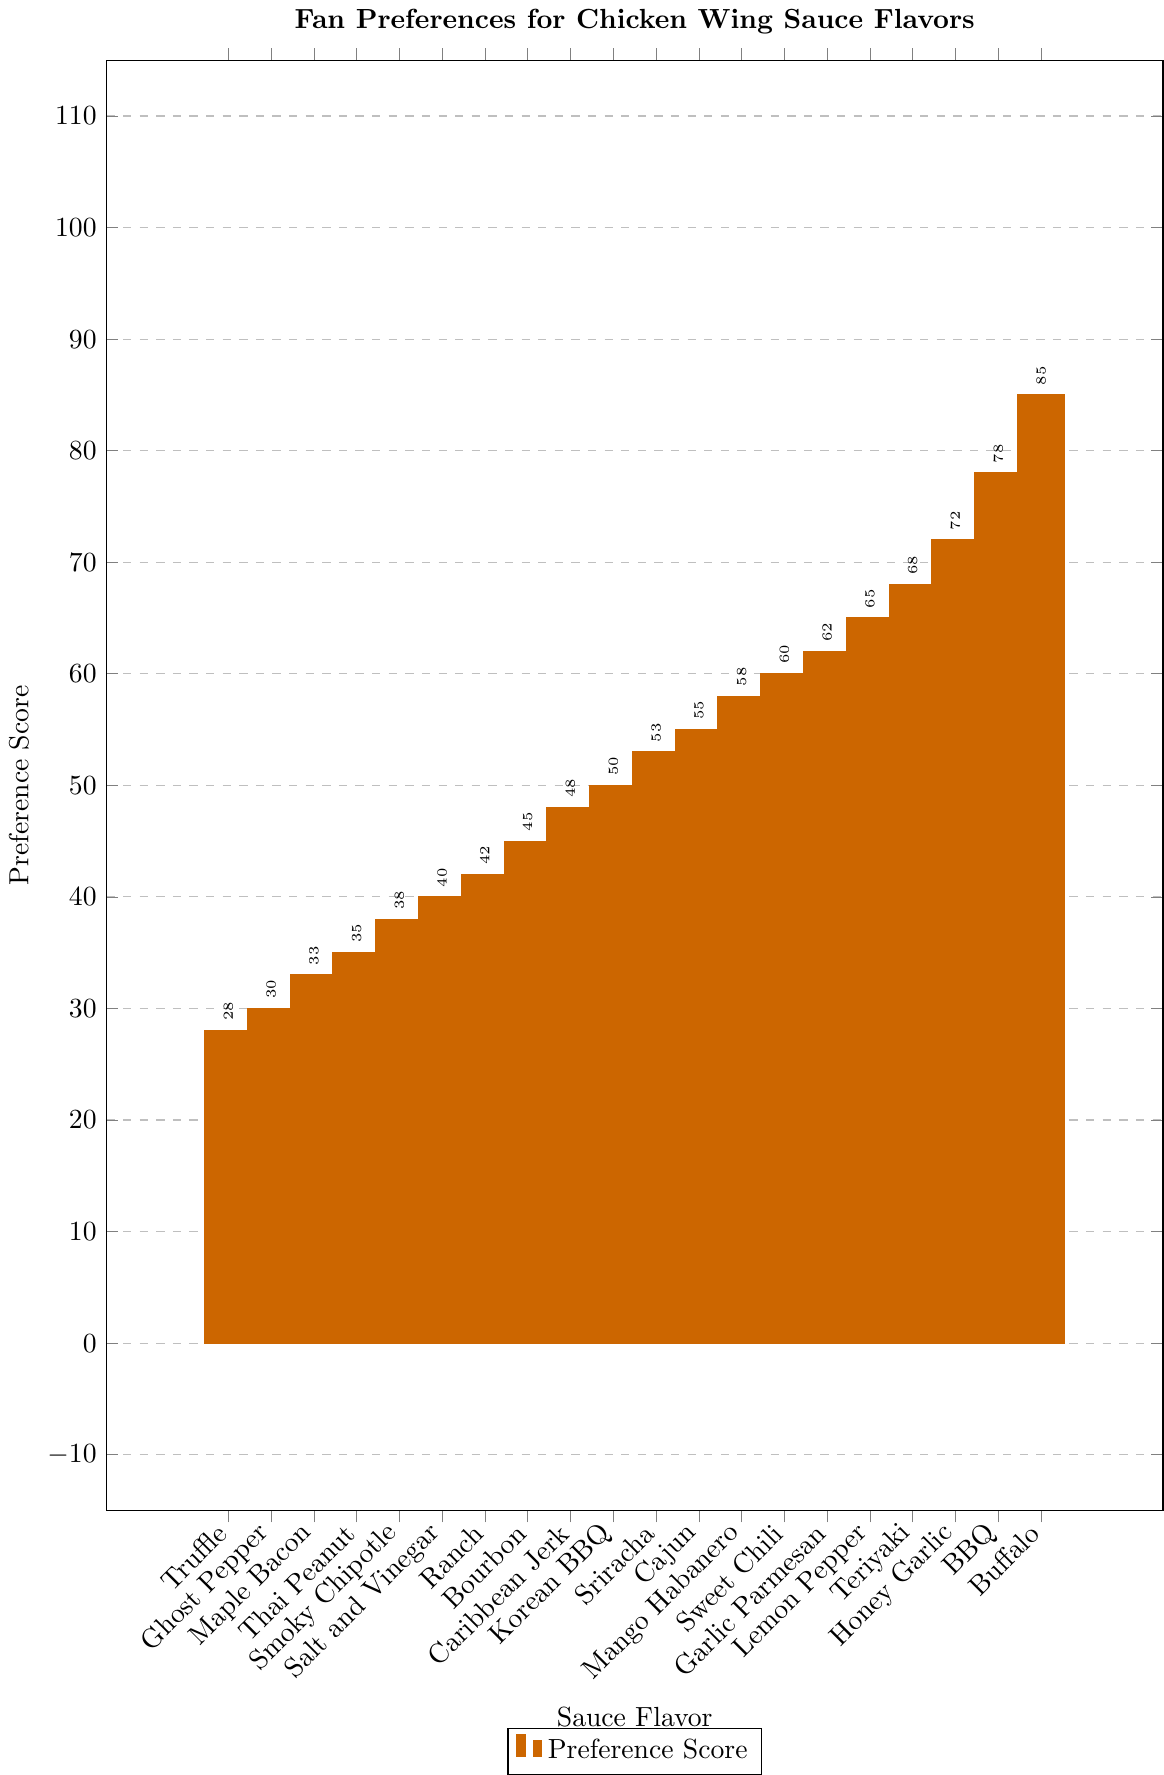What's the most preferred sauce flavor? The tallest bar in the bar chart represents the most preferred sauce flavor based on the preference score.
Answer: Buffalo Which sauce flavor has the lowest preference score? The shortest bar in the bar chart represents the sauce flavor with the lowest preference score.
Answer: Truffle What's the difference in preference scores between the Buffalo and BBQ flavors? Find the bar for Buffalo and note its preference score (85). Find the bar for BBQ and note its preference score (78). Subtract the BBQ score from the Buffalo score.
Answer: 7 How many sauce flavors have a preference score above 70? Identify the bars with heights corresponding to preference scores above 70. Count these bars.
Answer: 4 (Buffalo, BBQ, Honey Garlic, Teriyaki) Which two sauce flavors have the closest preference scores? Look for bars with similar heights and the smallest difference in their preference scores.
Answer: Sweet Chili and Garlic Parmesan If you combine the preference scores of Cajun and Sriracha, what total score would you get? Note the preference scores for Cajun (55) and Sriracha (53). Add these scores together.
Answer: 108 Which sauce flavor has a preference score closest to 60? Identify the bar that corresponds to a preference score closest to 60.
Answer: Sweet Chili By how many points does Lemon Pepper outscore Thai Peanut? Find the bar for Lemon Pepper and note its preference score (65). Find the bar for Thai Peanut and note its preference score (35). Subtract the Thai Peanut score from the Lemon Pepper score.
Answer: 30 What is the average preference score of the top 3 most preferred sauce flavors? Identify the preference scores of the top 3 sauce flavors (Buffalo: 85, BBQ: 78, Honey Garlic: 72). Calculate their average: (85 + 78 + 72) / 3.
Answer: 78.33 How many sauce flavors have a preference score less than or equal to 50? Identify the bars with heights corresponding to preference scores less than or equal to 50. Count these bars.
Answer: 6 (Thai Peanut, Maple Bacon, Ghost Pepper, Truffle, Salt and Vinegar, Korean BBQ) 